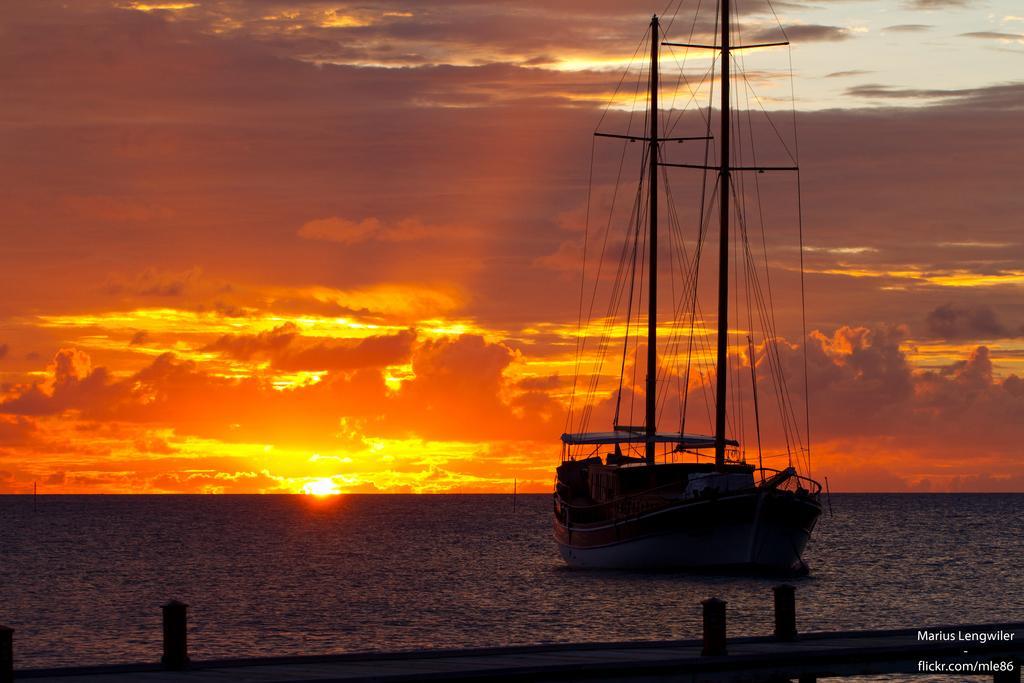Please provide a concise description of this image. In this picture we can see a ship on the water and on the ship there are poles with ropes. Behind the ship there is a sun and a sky. In front of the ship there is an object and on the image there is a watermark. 